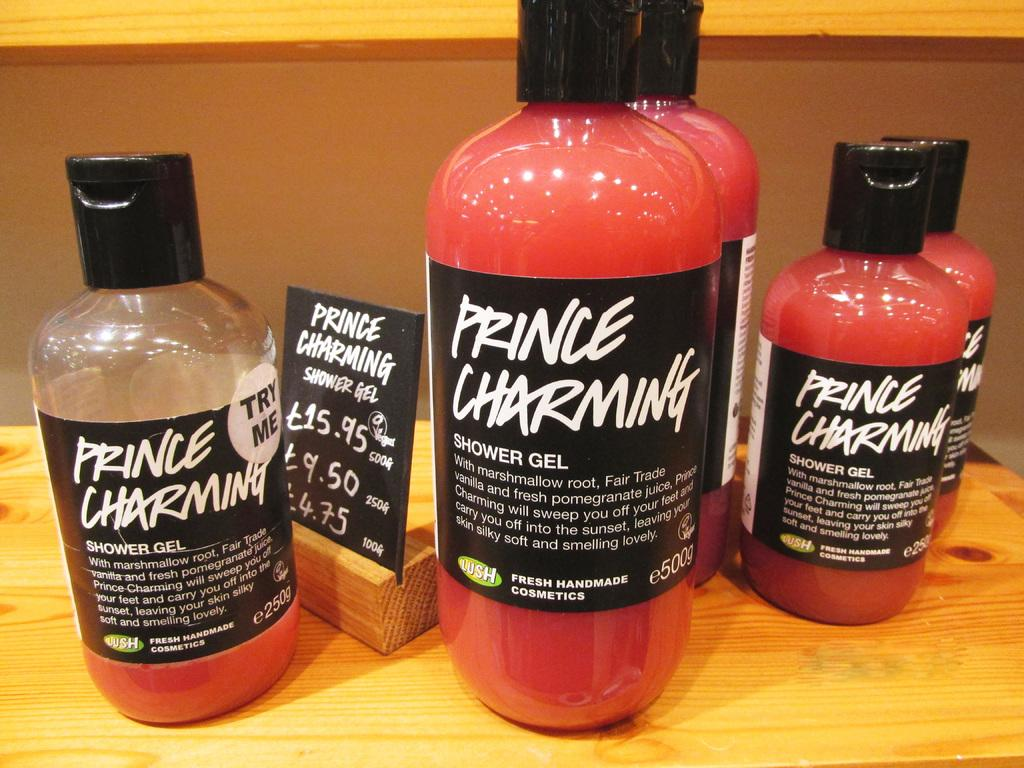Provide a one-sentence caption for the provided image. A display of shower gel products is arranged on a table. 